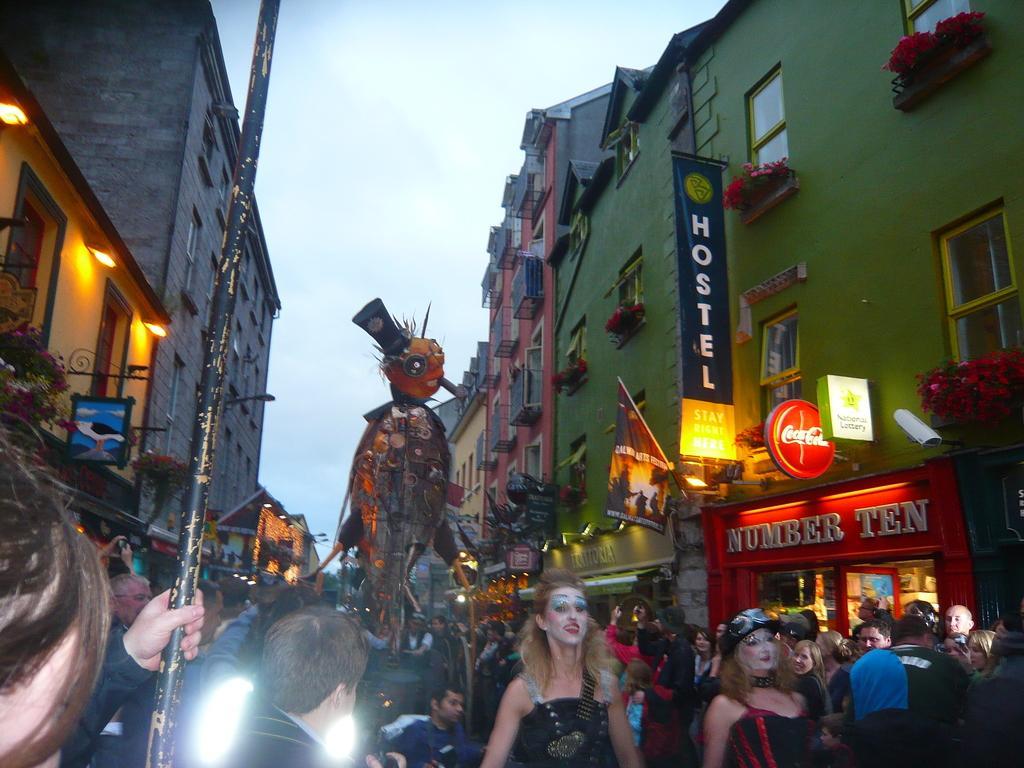How would you summarize this image in a sentence or two? The picture is taken on the streets of a city. At the bottom of the picture there are people and other objects. On the left there are buildings, flower pots and lights. On the right there are buildings, banners, lights and flower pots. Sky is cloudy. 